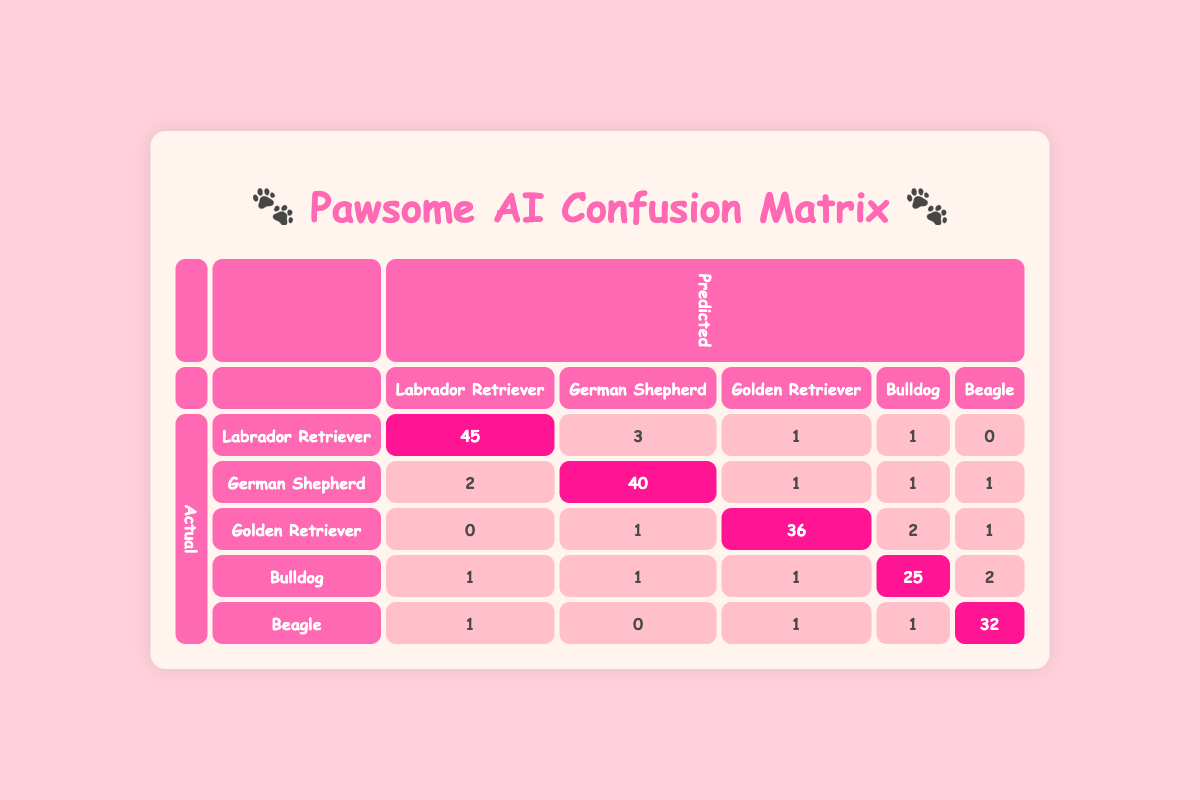What is the number of actual "Labrador Retriever" images that were correctly identified? The table shows that there were 45 images of "Labrador Retriever" that were predicted as "Labrador Retriever". This value is found on the diagonal of the confusion matrix where the actual and predicted values match.
Answer: 45 How many times was a "Beagle" misidentified as a "Bulldog"? According to the table, "Beagle" was predicted as "Bulldog" 1 time, which is found in the row for "Beagle" and the column for "Bulldog".
Answer: 1 What is the total number of "Golden Retriever" images that were not correctly identified? From the table, the actual number of "Golden Retriever" images is 40. Out of these, 36 were correctly identified, meaning 40 - 36 = 4 were not correctly identified (sum of false positives: 0 + 1 + 2 + 1 = 4).
Answer: 4 Did the AI model perform well for the "German Shepherd" category? The model predicted 40 out of 45 actual "German Shepherd" images correctly, as indicated by the diagonal value of 40, so yes, it performed well in this category.
Answer: Yes What is the total number of incorrect predictions for the "Bulldog" category? The actual number of "Bulldog" images is 30. The predictions that were incorrect include those predicted as "Labrador Retriever" (1), "German Shepherd" (1), "Golden Retriever" (1), and "Beagle" (2), totaling 1 + 1 + 1 + 2 = 5 incorrect predictions. Therefore, to find the correct predictions: 30 - 25= 5.
Answer: 5 What is the accuracy of the model for predicting the "Labrador Retriever" species? The accuracy for "Labrador Retriever" can be calculated by taking the correct predictions (45) and dividing it by the total actual images (50), giving us an accuracy of 45/50 = 0.9 or 90%.
Answer: 90% How many total images were predicted as "German Shepherd"? To find the total predicted as "German Shepherd," we add the values in the "German Shepherd" column: 3 + 40 + 1 + 1 + 0 = 45.
Answer: 45 Were there more correct predictions for "Beagle" or "Bulldog"? For "Beagle", the correct predictions are 32, while for "Bulldog" they are 25. Comparing these values, 32 > 25, confirming there were more correct predictions for "Beagle".
Answer: Beagle What is the proportion of "Golden Retriever" images that were correctly identified? The number of correct predictions for "Golden Retriever" is 36, and the actual number is 40. The proportion is calculated as 36/40 = 0.9 (or 90%).
Answer: 90% 